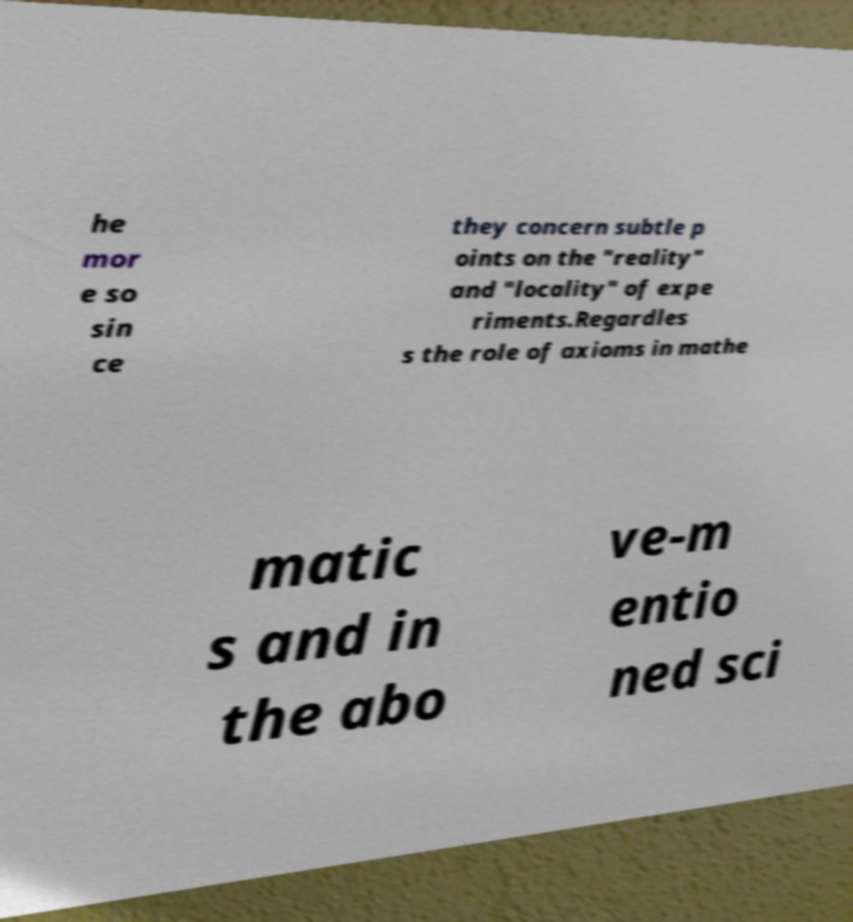Could you assist in decoding the text presented in this image and type it out clearly? he mor e so sin ce they concern subtle p oints on the "reality" and "locality" of expe riments.Regardles s the role of axioms in mathe matic s and in the abo ve-m entio ned sci 